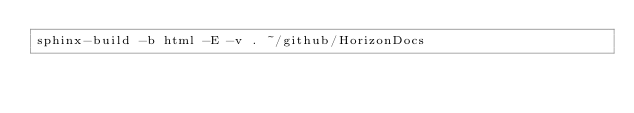Convert code to text. <code><loc_0><loc_0><loc_500><loc_500><_Bash_>sphinx-build -b html -E -v . ~/github/HorizonDocs
</code> 